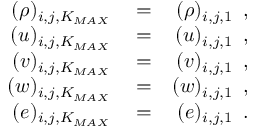<formula> <loc_0><loc_0><loc_500><loc_500>\begin{array} { r l r } { ( \rho ) _ { i , j , K _ { M A X } } } & = } & { ( \rho ) _ { i , j , 1 } \, , } \\ { ( u ) _ { i , j , K _ { M A X } } } & = } & { ( u ) _ { i , j , 1 } \, , } \\ { ( v ) _ { i , j , K _ { M A X } } } & = } & { ( v ) _ { i , j , 1 } \, , } \\ { ( w ) _ { i , j , K _ { M A X } } } & = } & { ( w ) _ { i , j , 1 } \, , } \\ { ( e ) _ { i , j , K _ { M A X } } } & = } & { ( e ) _ { i , j , 1 } \, . } \end{array}</formula> 